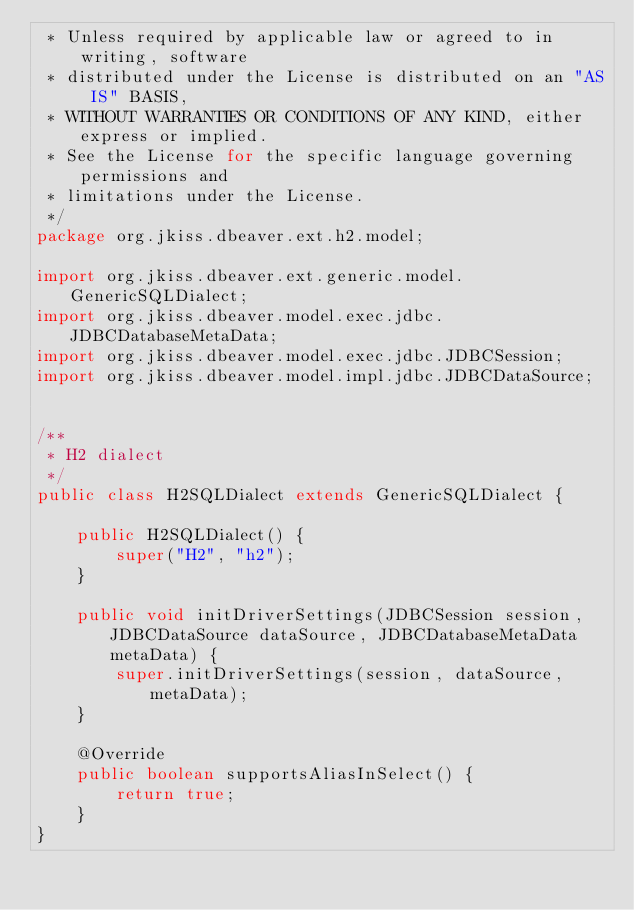<code> <loc_0><loc_0><loc_500><loc_500><_Java_> * Unless required by applicable law or agreed to in writing, software
 * distributed under the License is distributed on an "AS IS" BASIS,
 * WITHOUT WARRANTIES OR CONDITIONS OF ANY KIND, either express or implied.
 * See the License for the specific language governing permissions and
 * limitations under the License.
 */
package org.jkiss.dbeaver.ext.h2.model;

import org.jkiss.dbeaver.ext.generic.model.GenericSQLDialect;
import org.jkiss.dbeaver.model.exec.jdbc.JDBCDatabaseMetaData;
import org.jkiss.dbeaver.model.exec.jdbc.JDBCSession;
import org.jkiss.dbeaver.model.impl.jdbc.JDBCDataSource;


/**
 * H2 dialect
 */
public class H2SQLDialect extends GenericSQLDialect {

    public H2SQLDialect() {
        super("H2", "h2");
    }

    public void initDriverSettings(JDBCSession session, JDBCDataSource dataSource, JDBCDatabaseMetaData metaData) {
        super.initDriverSettings(session, dataSource, metaData);
    }

    @Override
    public boolean supportsAliasInSelect() {
        return true;
    }
}
</code> 